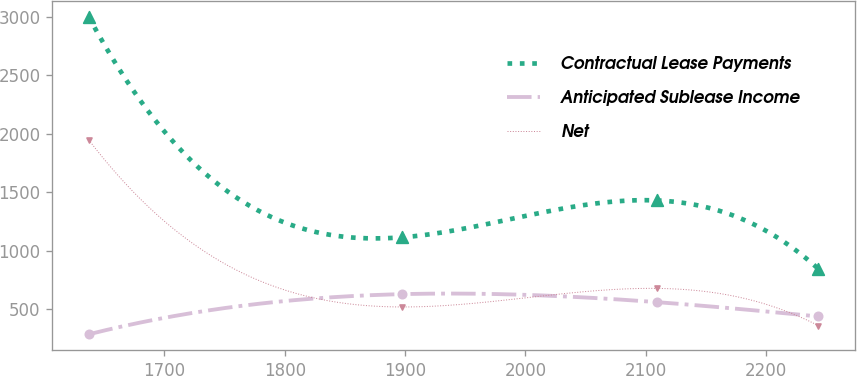<chart> <loc_0><loc_0><loc_500><loc_500><line_chart><ecel><fcel>Contractual Lease Payments<fcel>Anticipated Sublease Income<fcel>Net<nl><fcel>1636.95<fcel>3000.34<fcel>286.55<fcel>1948.02<nl><fcel>1897.67<fcel>1115.03<fcel>629.71<fcel>520.18<nl><fcel>2109.44<fcel>1429.61<fcel>561.38<fcel>678.83<nl><fcel>2243.45<fcel>846.56<fcel>439.07<fcel>361.53<nl></chart> 